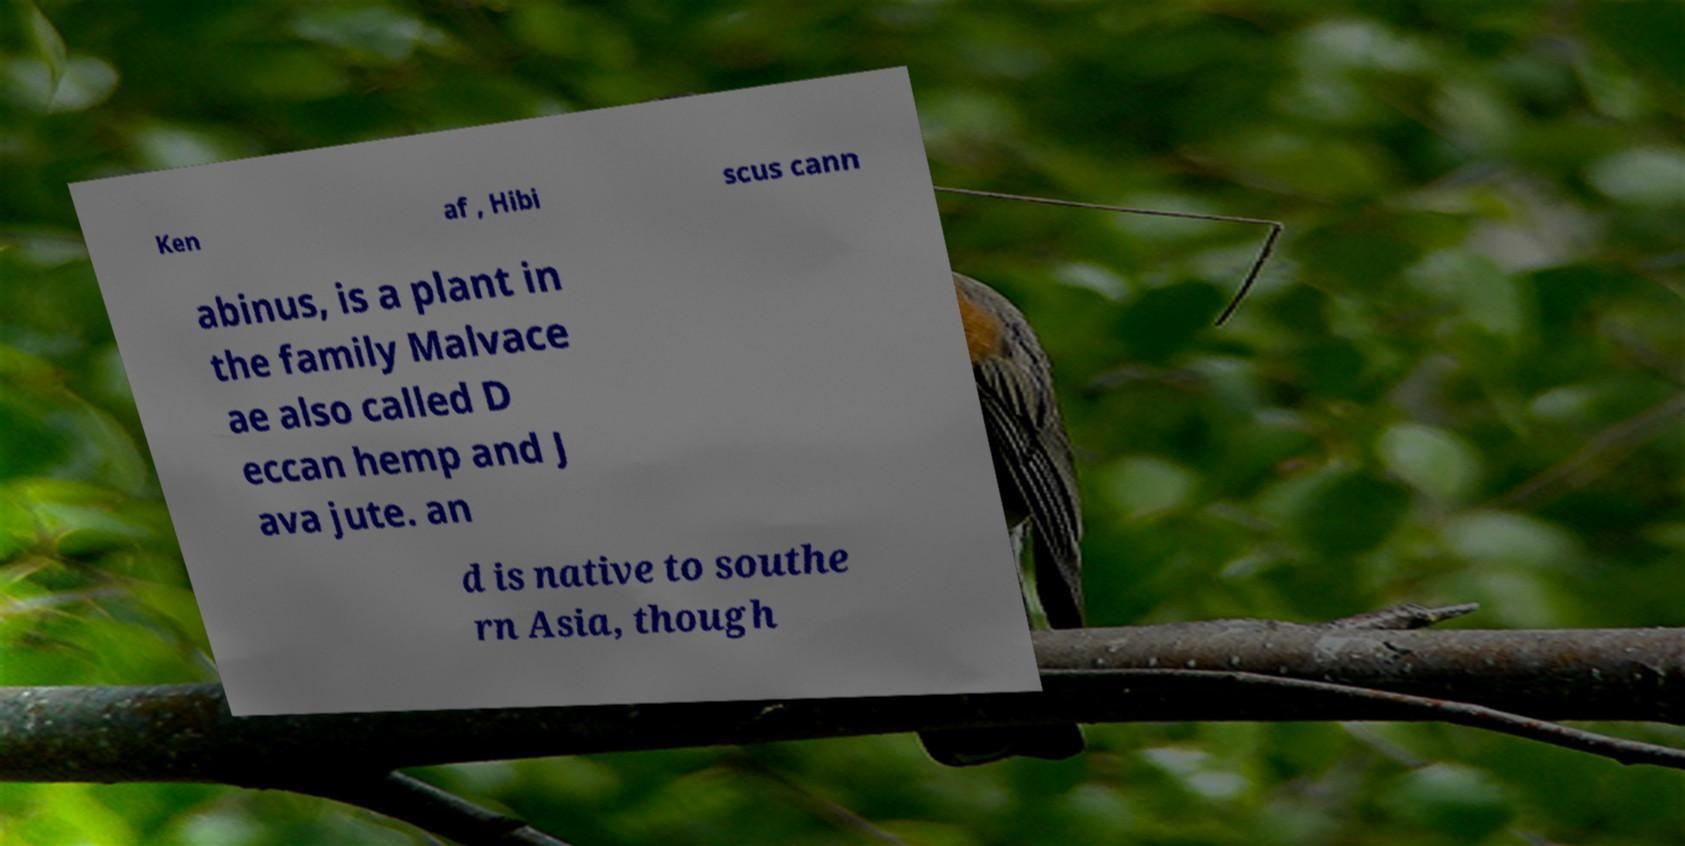Could you extract and type out the text from this image? Ken af , Hibi scus cann abinus, is a plant in the family Malvace ae also called D eccan hemp and J ava jute. an d is native to southe rn Asia, though 